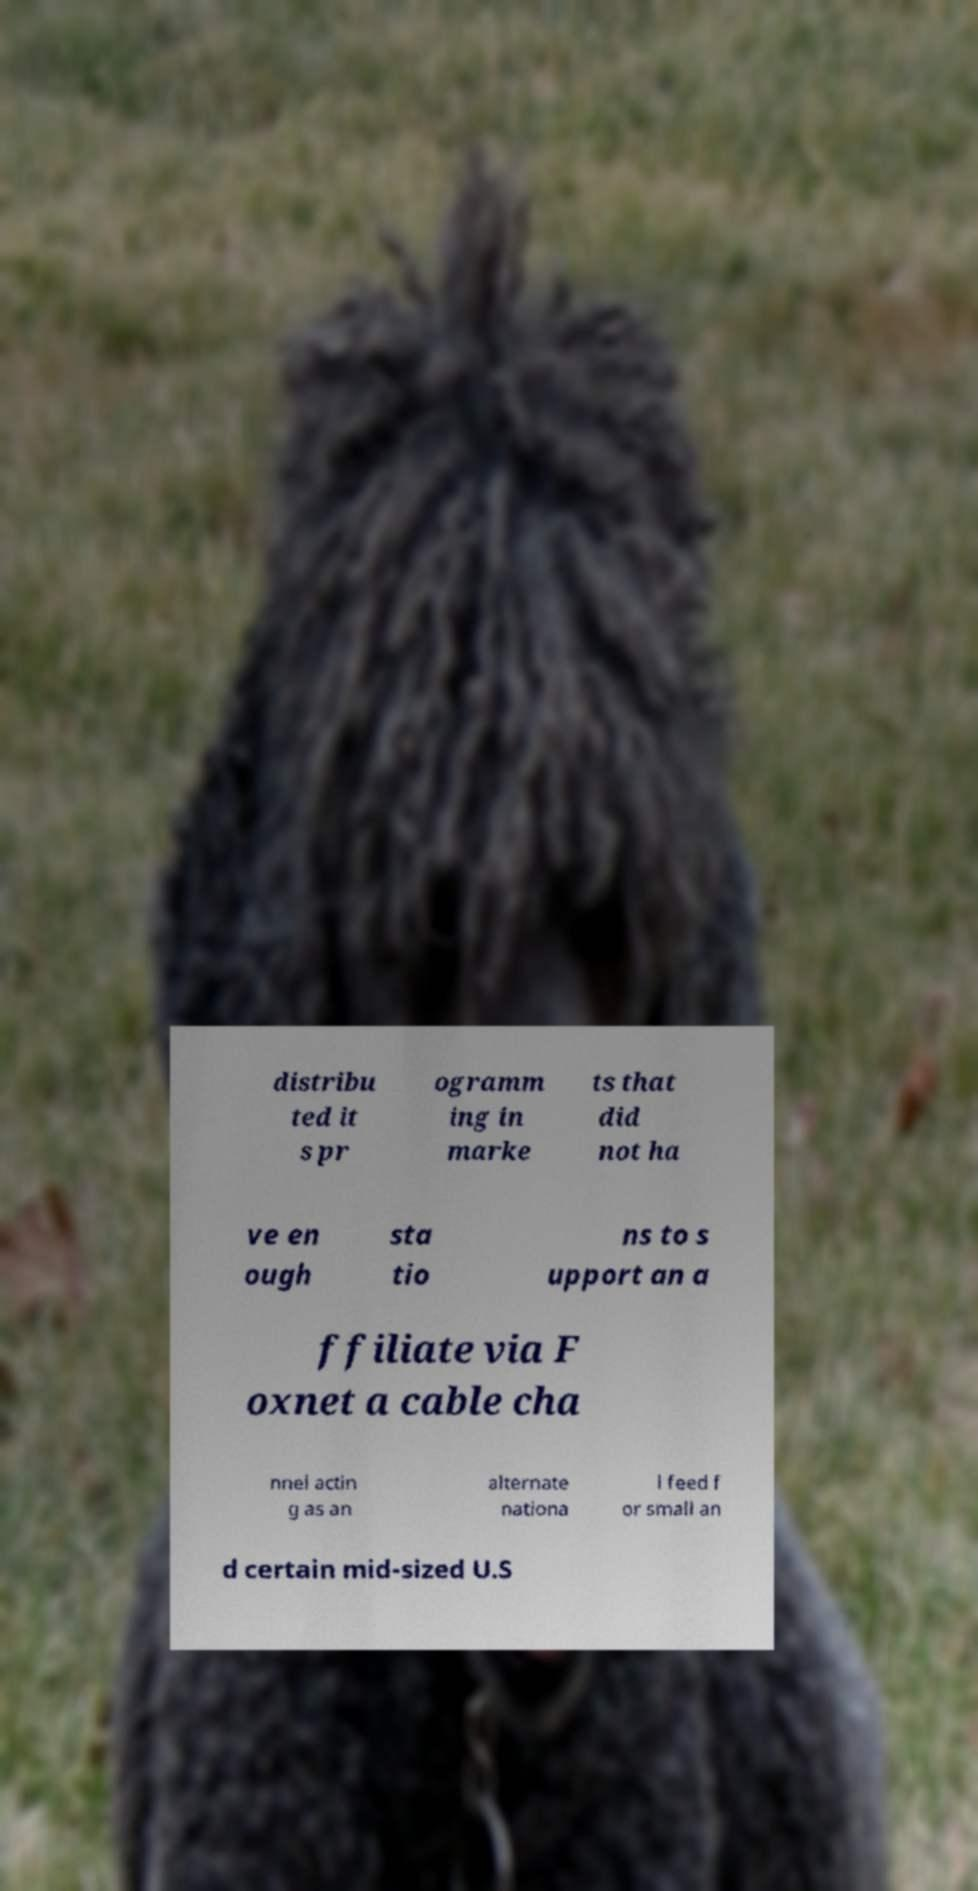Could you extract and type out the text from this image? distribu ted it s pr ogramm ing in marke ts that did not ha ve en ough sta tio ns to s upport an a ffiliate via F oxnet a cable cha nnel actin g as an alternate nationa l feed f or small an d certain mid-sized U.S 